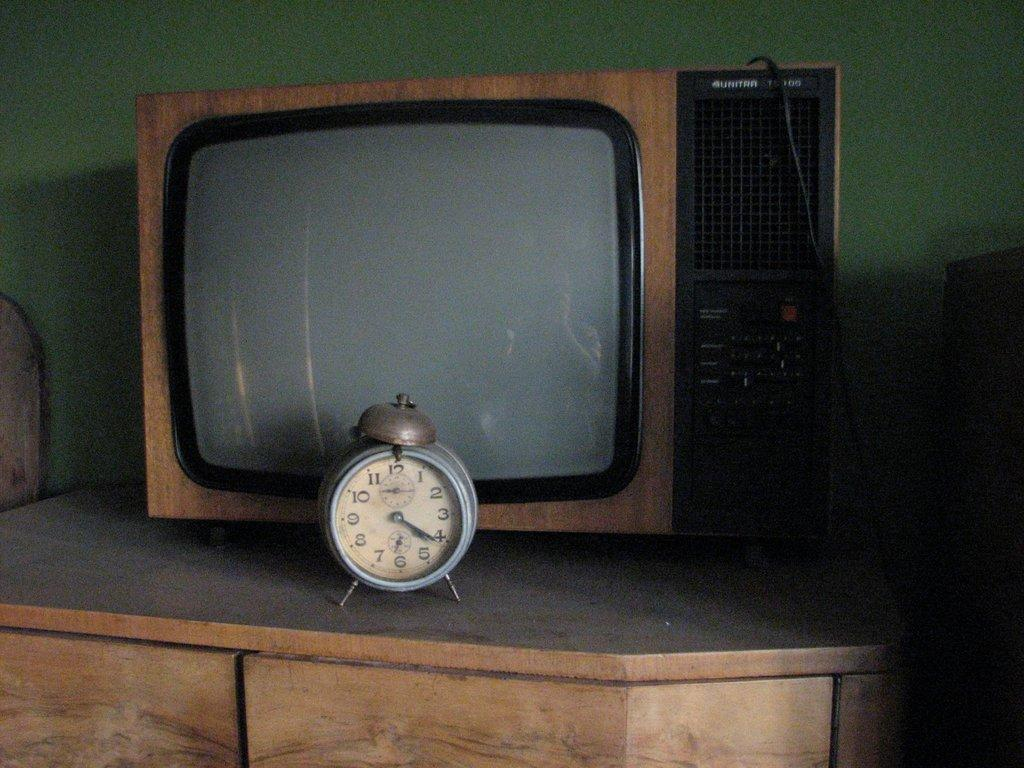<image>
Write a terse but informative summary of the picture. An alarm clock reading 4:21 sits in front of an old television. 